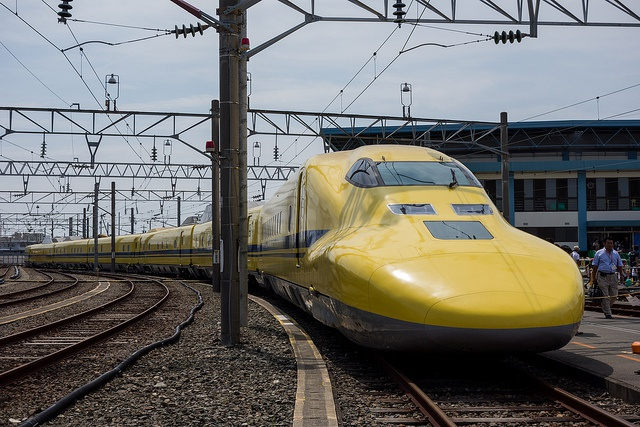Describe the objects in this image and their specific colors. I can see train in darkgray, black, tan, and olive tones, people in darkgray, black, gray, blue, and navy tones, handbag in darkgray, black, gray, olive, and maroon tones, people in darkgray, black, navy, and gray tones, and people in darkgray, black, and gray tones in this image. 